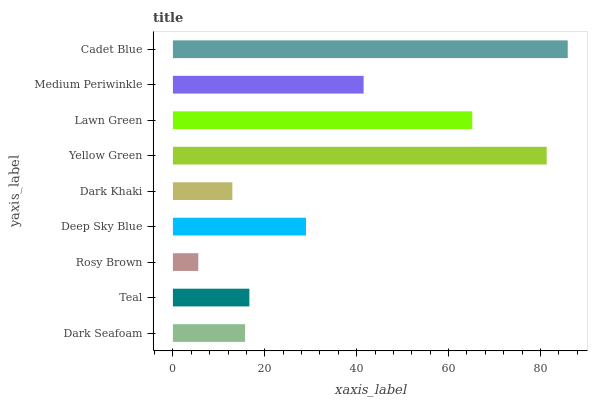Is Rosy Brown the minimum?
Answer yes or no. Yes. Is Cadet Blue the maximum?
Answer yes or no. Yes. Is Teal the minimum?
Answer yes or no. No. Is Teal the maximum?
Answer yes or no. No. Is Teal greater than Dark Seafoam?
Answer yes or no. Yes. Is Dark Seafoam less than Teal?
Answer yes or no. Yes. Is Dark Seafoam greater than Teal?
Answer yes or no. No. Is Teal less than Dark Seafoam?
Answer yes or no. No. Is Deep Sky Blue the high median?
Answer yes or no. Yes. Is Deep Sky Blue the low median?
Answer yes or no. Yes. Is Dark Seafoam the high median?
Answer yes or no. No. Is Dark Khaki the low median?
Answer yes or no. No. 